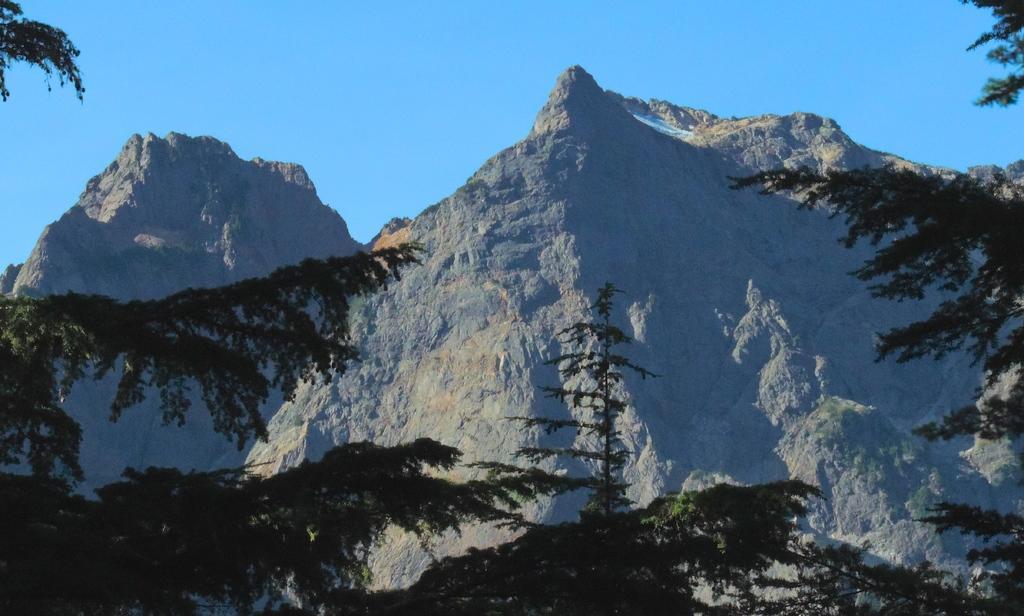Can you describe this image briefly? There are two big mountains. In Front of the mountains there are some trees. There is a sky behind the mountains. 